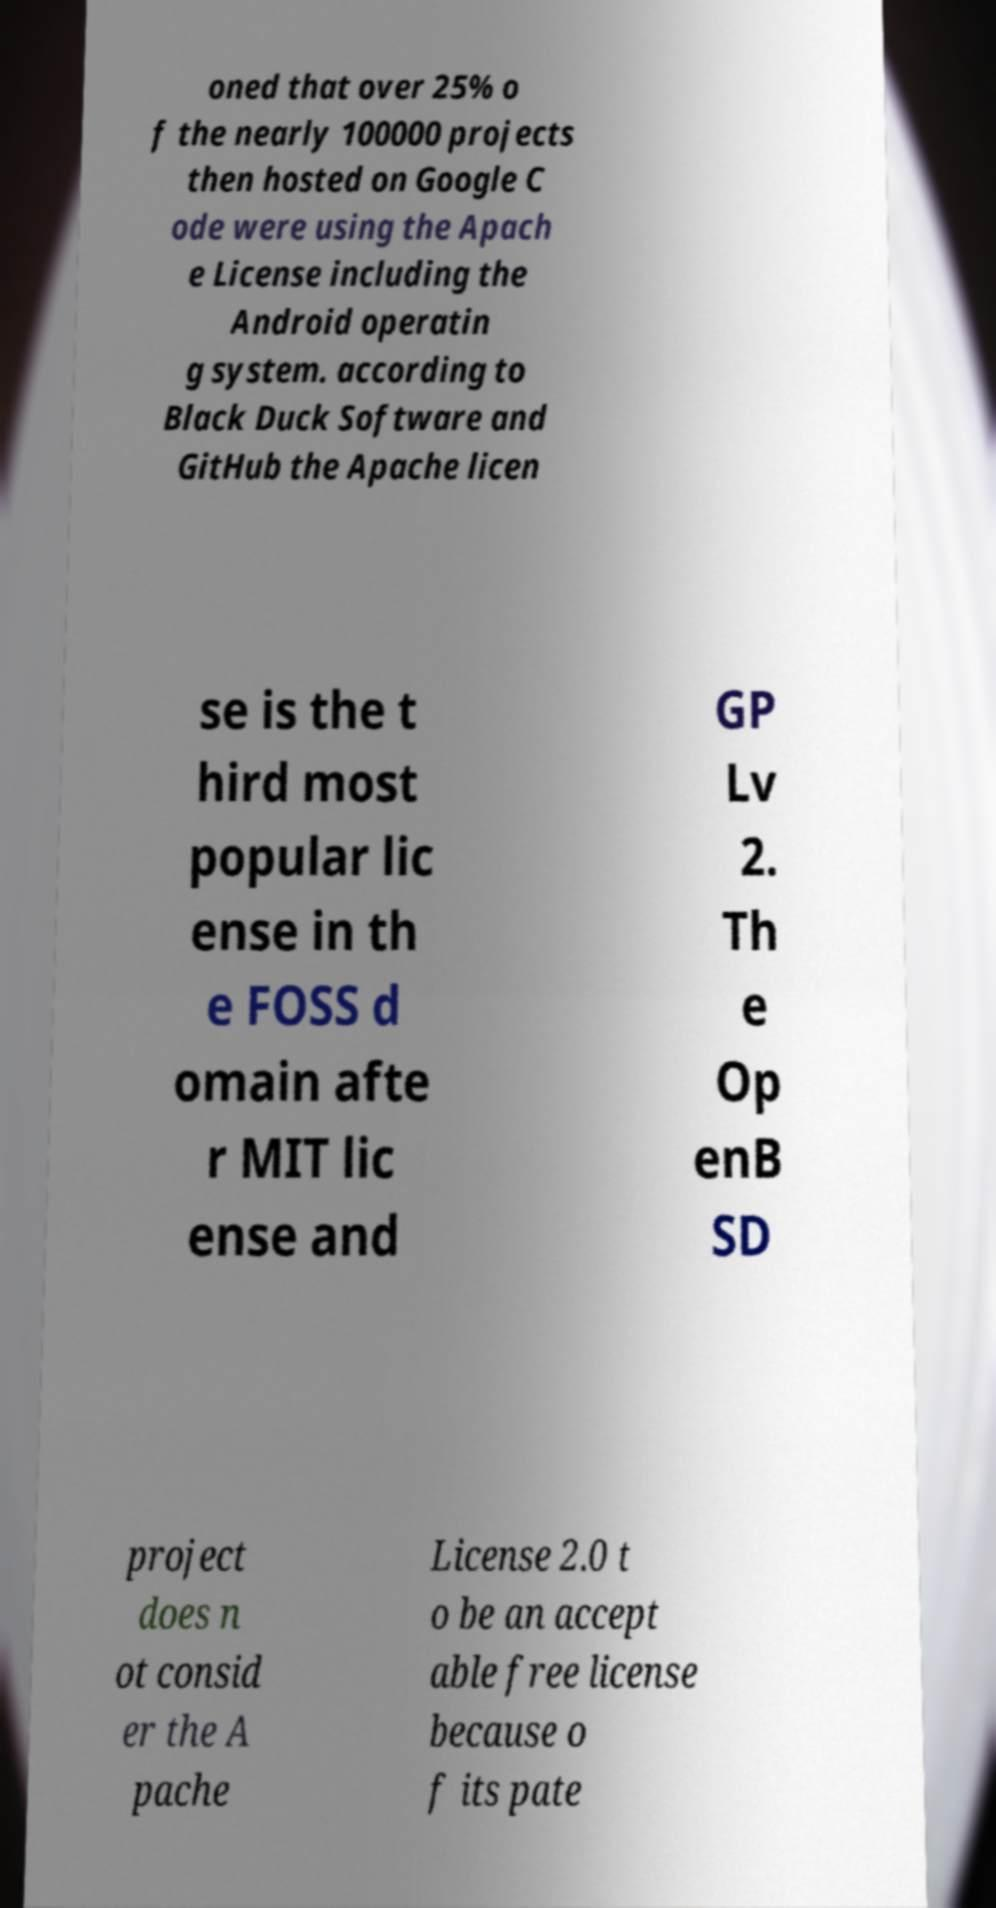Please read and relay the text visible in this image. What does it say? oned that over 25% o f the nearly 100000 projects then hosted on Google C ode were using the Apach e License including the Android operatin g system. according to Black Duck Software and GitHub the Apache licen se is the t hird most popular lic ense in th e FOSS d omain afte r MIT lic ense and GP Lv 2. Th e Op enB SD project does n ot consid er the A pache License 2.0 t o be an accept able free license because o f its pate 